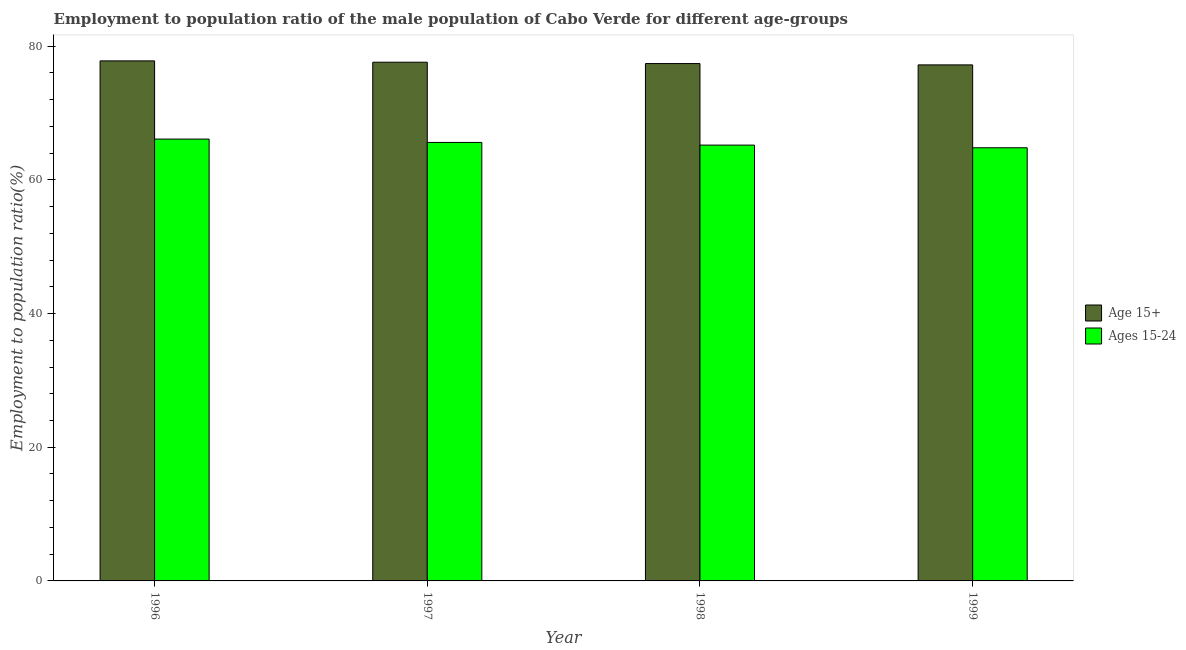How many different coloured bars are there?
Provide a short and direct response. 2. How many bars are there on the 1st tick from the left?
Your answer should be very brief. 2. How many bars are there on the 1st tick from the right?
Your response must be concise. 2. In how many cases, is the number of bars for a given year not equal to the number of legend labels?
Keep it short and to the point. 0. What is the employment to population ratio(age 15+) in 1998?
Offer a terse response. 77.4. Across all years, what is the maximum employment to population ratio(age 15+)?
Offer a terse response. 77.8. Across all years, what is the minimum employment to population ratio(age 15-24)?
Ensure brevity in your answer.  64.8. What is the total employment to population ratio(age 15+) in the graph?
Ensure brevity in your answer.  310. What is the difference between the employment to population ratio(age 15+) in 1998 and that in 1999?
Offer a very short reply. 0.2. What is the difference between the employment to population ratio(age 15+) in 1997 and the employment to population ratio(age 15-24) in 1998?
Ensure brevity in your answer.  0.2. What is the average employment to population ratio(age 15-24) per year?
Provide a succinct answer. 65.42. In how many years, is the employment to population ratio(age 15+) greater than 72 %?
Provide a succinct answer. 4. What is the ratio of the employment to population ratio(age 15+) in 1996 to that in 1997?
Offer a terse response. 1. Is the employment to population ratio(age 15+) in 1996 less than that in 1997?
Keep it short and to the point. No. Is the difference between the employment to population ratio(age 15+) in 1996 and 1997 greater than the difference between the employment to population ratio(age 15-24) in 1996 and 1997?
Your response must be concise. No. What is the difference between the highest and the second highest employment to population ratio(age 15+)?
Provide a succinct answer. 0.2. What is the difference between the highest and the lowest employment to population ratio(age 15+)?
Your response must be concise. 0.6. In how many years, is the employment to population ratio(age 15+) greater than the average employment to population ratio(age 15+) taken over all years?
Keep it short and to the point. 2. Is the sum of the employment to population ratio(age 15+) in 1997 and 1999 greater than the maximum employment to population ratio(age 15-24) across all years?
Ensure brevity in your answer.  Yes. What does the 1st bar from the left in 1998 represents?
Keep it short and to the point. Age 15+. What does the 2nd bar from the right in 1996 represents?
Your response must be concise. Age 15+. How many years are there in the graph?
Your response must be concise. 4. What is the difference between two consecutive major ticks on the Y-axis?
Make the answer very short. 20. Does the graph contain any zero values?
Ensure brevity in your answer.  No. Where does the legend appear in the graph?
Provide a short and direct response. Center right. How many legend labels are there?
Offer a very short reply. 2. What is the title of the graph?
Offer a terse response. Employment to population ratio of the male population of Cabo Verde for different age-groups. What is the label or title of the Y-axis?
Make the answer very short. Employment to population ratio(%). What is the Employment to population ratio(%) in Age 15+ in 1996?
Ensure brevity in your answer.  77.8. What is the Employment to population ratio(%) of Ages 15-24 in 1996?
Offer a very short reply. 66.1. What is the Employment to population ratio(%) of Age 15+ in 1997?
Offer a terse response. 77.6. What is the Employment to population ratio(%) in Ages 15-24 in 1997?
Give a very brief answer. 65.6. What is the Employment to population ratio(%) in Age 15+ in 1998?
Offer a very short reply. 77.4. What is the Employment to population ratio(%) of Ages 15-24 in 1998?
Ensure brevity in your answer.  65.2. What is the Employment to population ratio(%) in Age 15+ in 1999?
Give a very brief answer. 77.2. What is the Employment to population ratio(%) of Ages 15-24 in 1999?
Give a very brief answer. 64.8. Across all years, what is the maximum Employment to population ratio(%) in Age 15+?
Provide a short and direct response. 77.8. Across all years, what is the maximum Employment to population ratio(%) of Ages 15-24?
Ensure brevity in your answer.  66.1. Across all years, what is the minimum Employment to population ratio(%) of Age 15+?
Give a very brief answer. 77.2. Across all years, what is the minimum Employment to population ratio(%) in Ages 15-24?
Your answer should be compact. 64.8. What is the total Employment to population ratio(%) of Age 15+ in the graph?
Keep it short and to the point. 310. What is the total Employment to population ratio(%) in Ages 15-24 in the graph?
Offer a terse response. 261.7. What is the difference between the Employment to population ratio(%) of Age 15+ in 1996 and that in 1999?
Keep it short and to the point. 0.6. What is the difference between the Employment to population ratio(%) in Age 15+ in 1997 and that in 1999?
Provide a short and direct response. 0.4. What is the difference between the Employment to population ratio(%) of Ages 15-24 in 1998 and that in 1999?
Make the answer very short. 0.4. What is the average Employment to population ratio(%) of Age 15+ per year?
Your response must be concise. 77.5. What is the average Employment to population ratio(%) of Ages 15-24 per year?
Make the answer very short. 65.42. In the year 1998, what is the difference between the Employment to population ratio(%) in Age 15+ and Employment to population ratio(%) in Ages 15-24?
Provide a short and direct response. 12.2. In the year 1999, what is the difference between the Employment to population ratio(%) of Age 15+ and Employment to population ratio(%) of Ages 15-24?
Give a very brief answer. 12.4. What is the ratio of the Employment to population ratio(%) in Ages 15-24 in 1996 to that in 1997?
Your answer should be very brief. 1.01. What is the ratio of the Employment to population ratio(%) in Ages 15-24 in 1996 to that in 1998?
Provide a short and direct response. 1.01. What is the ratio of the Employment to population ratio(%) of Ages 15-24 in 1996 to that in 1999?
Offer a terse response. 1.02. What is the ratio of the Employment to population ratio(%) of Age 15+ in 1997 to that in 1998?
Keep it short and to the point. 1. What is the ratio of the Employment to population ratio(%) in Age 15+ in 1997 to that in 1999?
Provide a succinct answer. 1.01. What is the ratio of the Employment to population ratio(%) in Ages 15-24 in 1997 to that in 1999?
Your answer should be compact. 1.01. What is the ratio of the Employment to population ratio(%) in Age 15+ in 1998 to that in 1999?
Provide a succinct answer. 1. What is the difference between the highest and the second highest Employment to population ratio(%) in Ages 15-24?
Provide a short and direct response. 0.5. What is the difference between the highest and the lowest Employment to population ratio(%) in Age 15+?
Make the answer very short. 0.6. What is the difference between the highest and the lowest Employment to population ratio(%) of Ages 15-24?
Give a very brief answer. 1.3. 